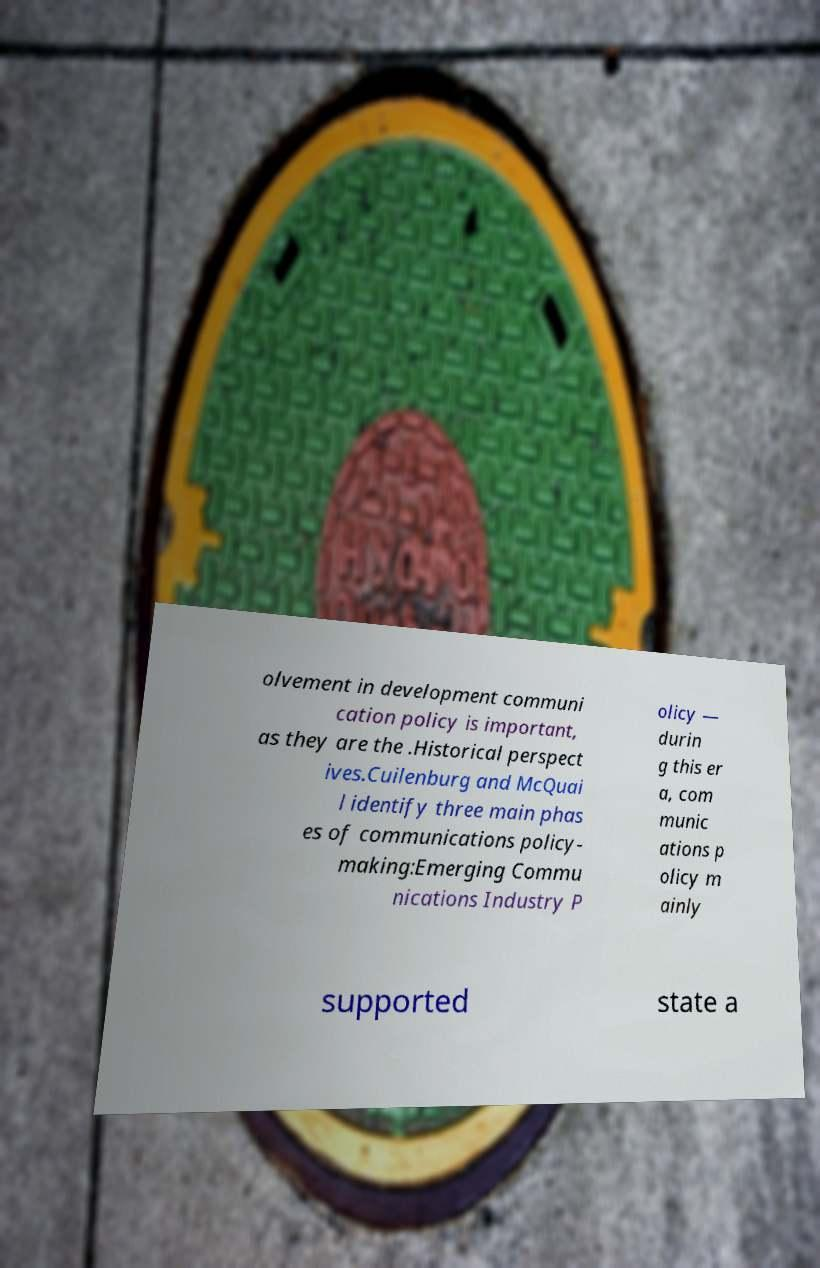Can you read and provide the text displayed in the image?This photo seems to have some interesting text. Can you extract and type it out for me? olvement in development communi cation policy is important, as they are the .Historical perspect ives.Cuilenburg and McQuai l identify three main phas es of communications policy- making:Emerging Commu nications Industry P olicy — durin g this er a, com munic ations p olicy m ainly supported state a 